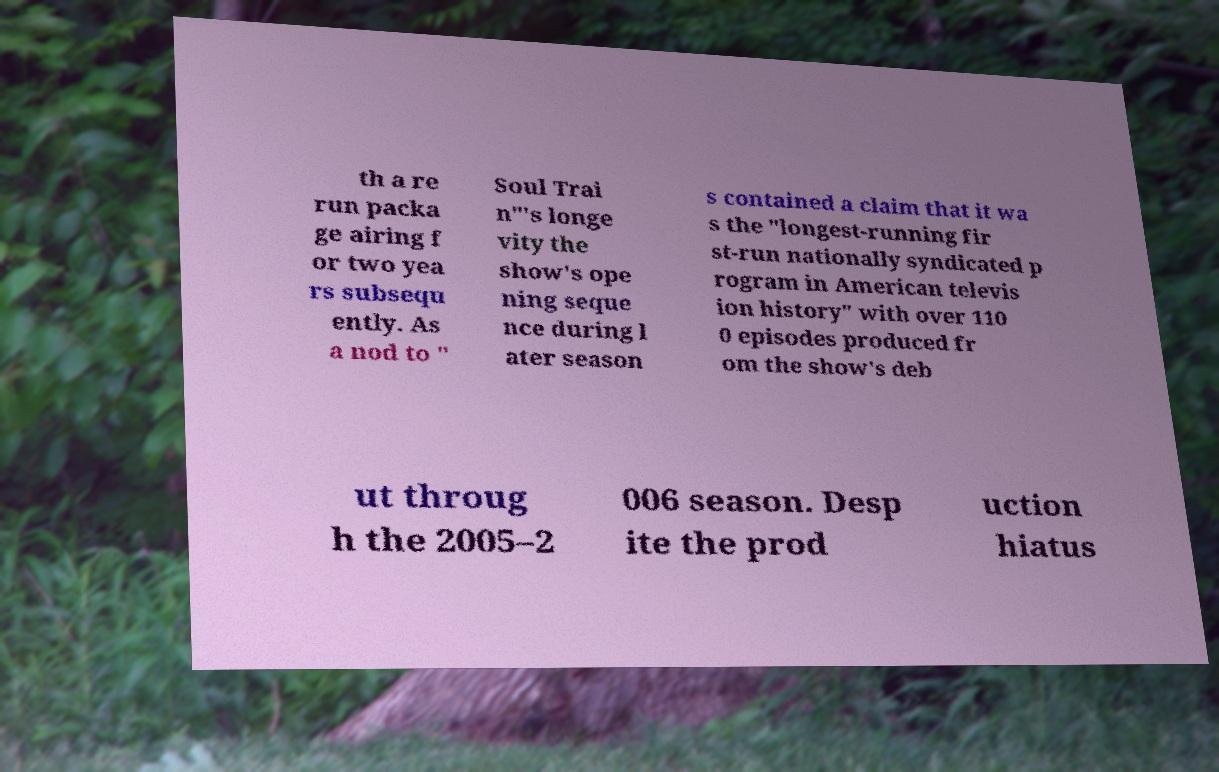For documentation purposes, I need the text within this image transcribed. Could you provide that? th a re run packa ge airing f or two yea rs subsequ ently. As a nod to " Soul Trai n"'s longe vity the show's ope ning seque nce during l ater season s contained a claim that it wa s the "longest-running fir st-run nationally syndicated p rogram in American televis ion history" with over 110 0 episodes produced fr om the show's deb ut throug h the 2005–2 006 season. Desp ite the prod uction hiatus 